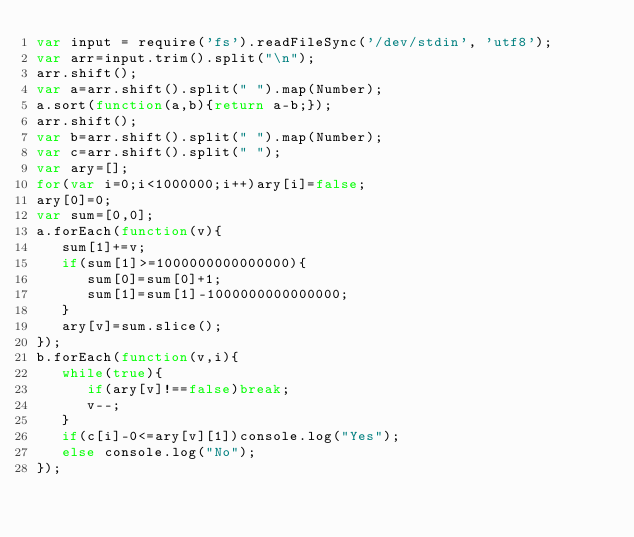Convert code to text. <code><loc_0><loc_0><loc_500><loc_500><_JavaScript_>var input = require('fs').readFileSync('/dev/stdin', 'utf8');
var arr=input.trim().split("\n");
arr.shift();
var a=arr.shift().split(" ").map(Number);
a.sort(function(a,b){return a-b;});
arr.shift();
var b=arr.shift().split(" ").map(Number);
var c=arr.shift().split(" ");
var ary=[];
for(var i=0;i<1000000;i++)ary[i]=false;
ary[0]=0;
var sum=[0,0];
a.forEach(function(v){
   sum[1]+=v;
   if(sum[1]>=1000000000000000){
      sum[0]=sum[0]+1;
      sum[1]=sum[1]-1000000000000000;
   }
   ary[v]=sum.slice();
});
b.forEach(function(v,i){
   while(true){
      if(ary[v]!==false)break;
      v--;
   }
   if(c[i]-0<=ary[v][1])console.log("Yes");
   else console.log("No");
});</code> 